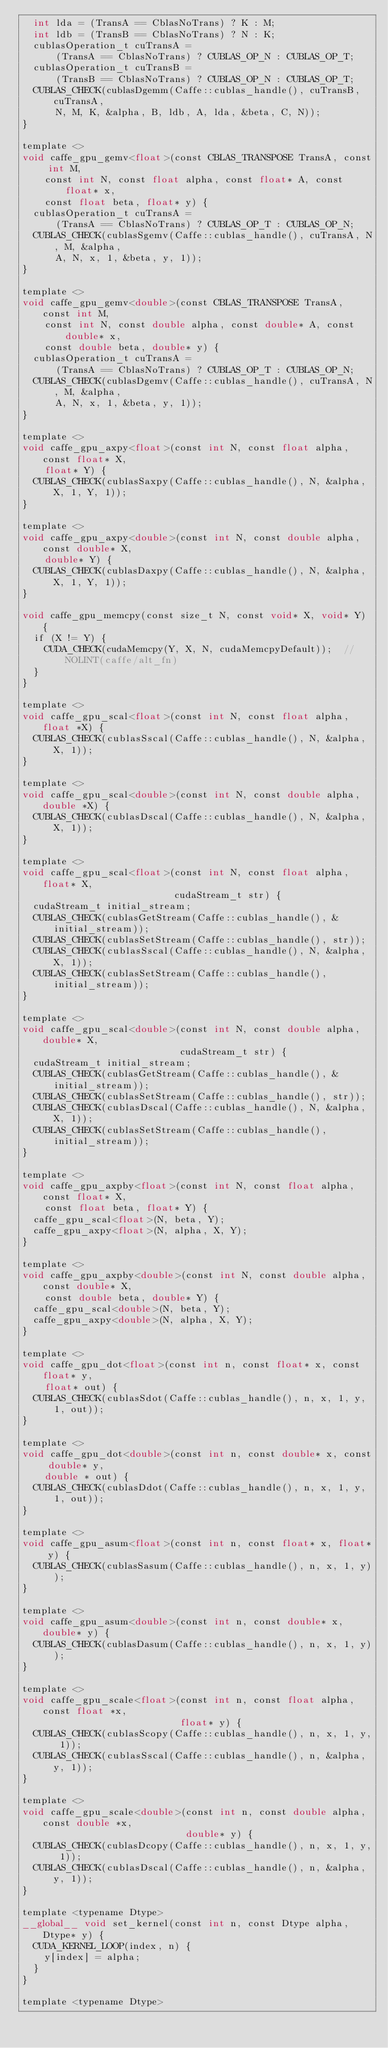<code> <loc_0><loc_0><loc_500><loc_500><_Cuda_>  int lda = (TransA == CblasNoTrans) ? K : M;
  int ldb = (TransB == CblasNoTrans) ? N : K;
  cublasOperation_t cuTransA =
      (TransA == CblasNoTrans) ? CUBLAS_OP_N : CUBLAS_OP_T;
  cublasOperation_t cuTransB =
      (TransB == CblasNoTrans) ? CUBLAS_OP_N : CUBLAS_OP_T;
  CUBLAS_CHECK(cublasDgemm(Caffe::cublas_handle(), cuTransB, cuTransA,
      N, M, K, &alpha, B, ldb, A, lda, &beta, C, N));
}

template <>
void caffe_gpu_gemv<float>(const CBLAS_TRANSPOSE TransA, const int M,
    const int N, const float alpha, const float* A, const float* x,
    const float beta, float* y) {
  cublasOperation_t cuTransA =
      (TransA == CblasNoTrans) ? CUBLAS_OP_T : CUBLAS_OP_N;
  CUBLAS_CHECK(cublasSgemv(Caffe::cublas_handle(), cuTransA, N, M, &alpha,
      A, N, x, 1, &beta, y, 1));
}

template <>
void caffe_gpu_gemv<double>(const CBLAS_TRANSPOSE TransA, const int M,
    const int N, const double alpha, const double* A, const double* x,
    const double beta, double* y) {
  cublasOperation_t cuTransA =
      (TransA == CblasNoTrans) ? CUBLAS_OP_T : CUBLAS_OP_N;
  CUBLAS_CHECK(cublasDgemv(Caffe::cublas_handle(), cuTransA, N, M, &alpha,
      A, N, x, 1, &beta, y, 1));
}

template <>
void caffe_gpu_axpy<float>(const int N, const float alpha, const float* X,
    float* Y) {
  CUBLAS_CHECK(cublasSaxpy(Caffe::cublas_handle(), N, &alpha, X, 1, Y, 1));
}

template <>
void caffe_gpu_axpy<double>(const int N, const double alpha, const double* X,
    double* Y) {
  CUBLAS_CHECK(cublasDaxpy(Caffe::cublas_handle(), N, &alpha, X, 1, Y, 1));
}

void caffe_gpu_memcpy(const size_t N, const void* X, void* Y) {
  if (X != Y) {
    CUDA_CHECK(cudaMemcpy(Y, X, N, cudaMemcpyDefault));  // NOLINT(caffe/alt_fn)
  }
}

template <>
void caffe_gpu_scal<float>(const int N, const float alpha, float *X) {
  CUBLAS_CHECK(cublasSscal(Caffe::cublas_handle(), N, &alpha, X, 1));
}

template <>
void caffe_gpu_scal<double>(const int N, const double alpha, double *X) {
  CUBLAS_CHECK(cublasDscal(Caffe::cublas_handle(), N, &alpha, X, 1));
}

template <>
void caffe_gpu_scal<float>(const int N, const float alpha, float* X,
                           cudaStream_t str) {
  cudaStream_t initial_stream;
  CUBLAS_CHECK(cublasGetStream(Caffe::cublas_handle(), &initial_stream));
  CUBLAS_CHECK(cublasSetStream(Caffe::cublas_handle(), str));
  CUBLAS_CHECK(cublasSscal(Caffe::cublas_handle(), N, &alpha, X, 1));
  CUBLAS_CHECK(cublasSetStream(Caffe::cublas_handle(), initial_stream));
}

template <>
void caffe_gpu_scal<double>(const int N, const double alpha, double* X,
                            cudaStream_t str) {
  cudaStream_t initial_stream;
  CUBLAS_CHECK(cublasGetStream(Caffe::cublas_handle(), &initial_stream));
  CUBLAS_CHECK(cublasSetStream(Caffe::cublas_handle(), str));
  CUBLAS_CHECK(cublasDscal(Caffe::cublas_handle(), N, &alpha, X, 1));
  CUBLAS_CHECK(cublasSetStream(Caffe::cublas_handle(), initial_stream));
}

template <>
void caffe_gpu_axpby<float>(const int N, const float alpha, const float* X,
    const float beta, float* Y) {
  caffe_gpu_scal<float>(N, beta, Y);
  caffe_gpu_axpy<float>(N, alpha, X, Y);
}

template <>
void caffe_gpu_axpby<double>(const int N, const double alpha, const double* X,
    const double beta, double* Y) {
  caffe_gpu_scal<double>(N, beta, Y);
  caffe_gpu_axpy<double>(N, alpha, X, Y);
}

template <>
void caffe_gpu_dot<float>(const int n, const float* x, const float* y,
    float* out) {
  CUBLAS_CHECK(cublasSdot(Caffe::cublas_handle(), n, x, 1, y, 1, out));
}

template <>
void caffe_gpu_dot<double>(const int n, const double* x, const double* y,
    double * out) {
  CUBLAS_CHECK(cublasDdot(Caffe::cublas_handle(), n, x, 1, y, 1, out));
}

template <>
void caffe_gpu_asum<float>(const int n, const float* x, float* y) {
  CUBLAS_CHECK(cublasSasum(Caffe::cublas_handle(), n, x, 1, y));
}

template <>
void caffe_gpu_asum<double>(const int n, const double* x, double* y) {
  CUBLAS_CHECK(cublasDasum(Caffe::cublas_handle(), n, x, 1, y));
}

template <>
void caffe_gpu_scale<float>(const int n, const float alpha, const float *x,
                            float* y) {
  CUBLAS_CHECK(cublasScopy(Caffe::cublas_handle(), n, x, 1, y, 1));
  CUBLAS_CHECK(cublasSscal(Caffe::cublas_handle(), n, &alpha, y, 1));
}

template <>
void caffe_gpu_scale<double>(const int n, const double alpha, const double *x,
                             double* y) {
  CUBLAS_CHECK(cublasDcopy(Caffe::cublas_handle(), n, x, 1, y, 1));
  CUBLAS_CHECK(cublasDscal(Caffe::cublas_handle(), n, &alpha, y, 1));
}

template <typename Dtype>
__global__ void set_kernel(const int n, const Dtype alpha, Dtype* y) {
  CUDA_KERNEL_LOOP(index, n) {
    y[index] = alpha;
  }
}

template <typename Dtype></code> 